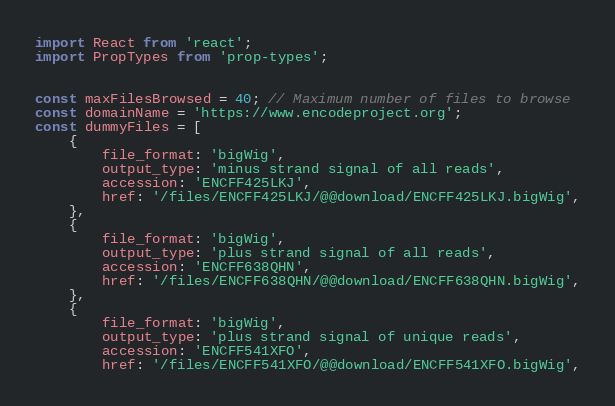Convert code to text. <code><loc_0><loc_0><loc_500><loc_500><_JavaScript_>import React from 'react';
import PropTypes from 'prop-types';


const maxFilesBrowsed = 40; // Maximum number of files to browse
const domainName = 'https://www.encodeproject.org';
const dummyFiles = [
    {
        file_format: 'bigWig',
        output_type: 'minus strand signal of all reads',
        accession: 'ENCFF425LKJ',
        href: '/files/ENCFF425LKJ/@@download/ENCFF425LKJ.bigWig',
    },
    {
        file_format: 'bigWig',
        output_type: 'plus strand signal of all reads',
        accession: 'ENCFF638QHN',
        href: '/files/ENCFF638QHN/@@download/ENCFF638QHN.bigWig',
    },
    {
        file_format: 'bigWig',
        output_type: 'plus strand signal of unique reads',
        accession: 'ENCFF541XFO',
        href: '/files/ENCFF541XFO/@@download/ENCFF541XFO.bigWig',</code> 